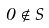Convert formula to latex. <formula><loc_0><loc_0><loc_500><loc_500>0 \notin S</formula> 